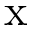<formula> <loc_0><loc_0><loc_500><loc_500>x</formula> 